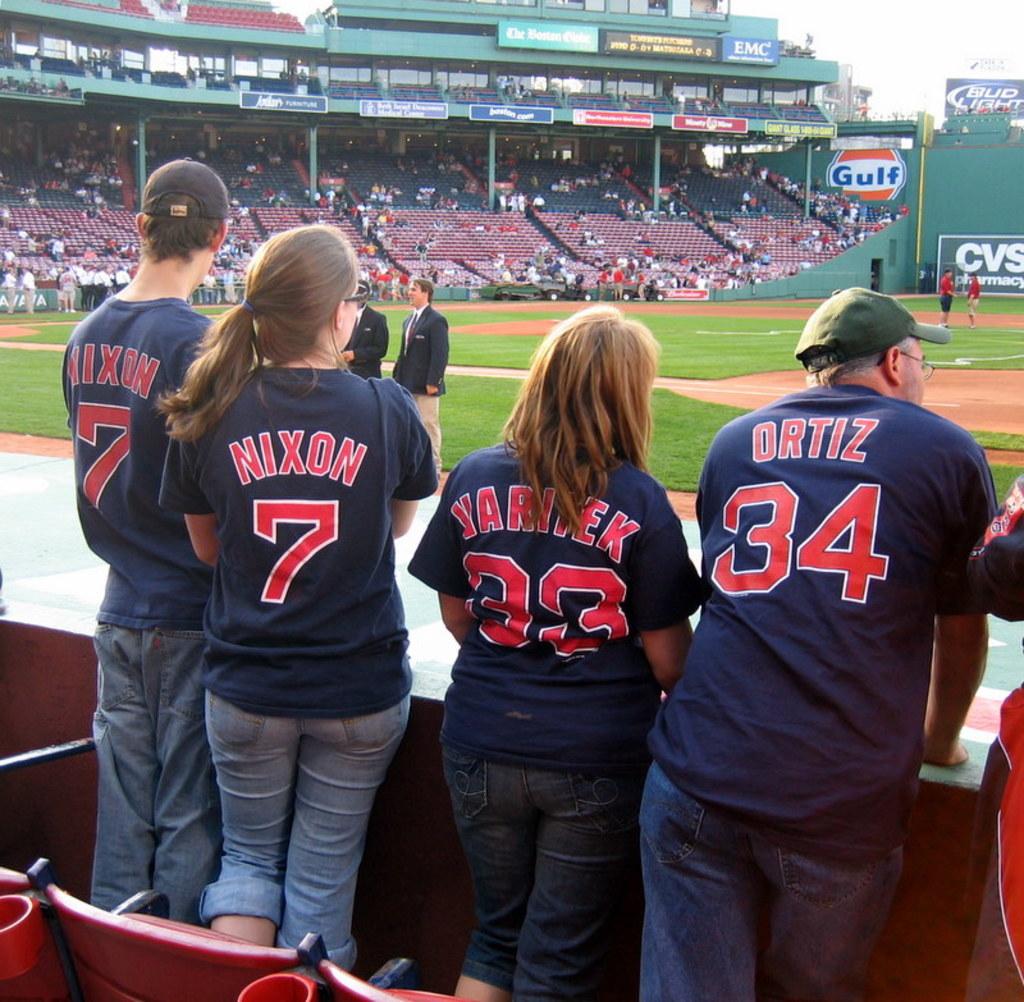What player is #7?
Your answer should be compact. Nixon. What number is ortiz?
Give a very brief answer. 34. 